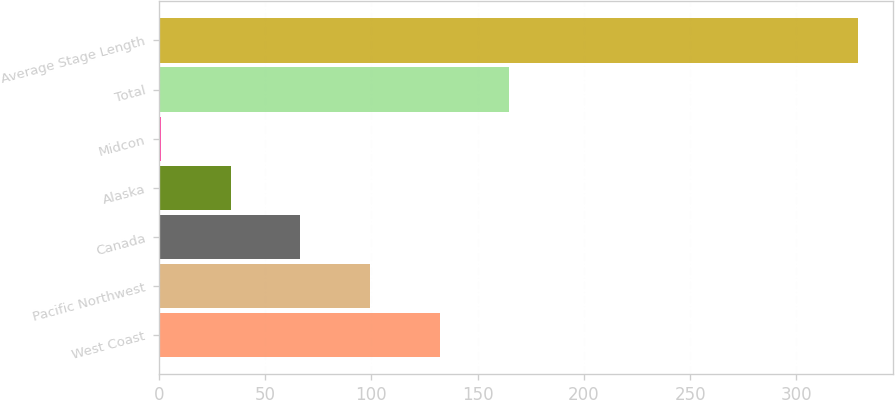Convert chart to OTSL. <chart><loc_0><loc_0><loc_500><loc_500><bar_chart><fcel>West Coast<fcel>Pacific Northwest<fcel>Canada<fcel>Alaska<fcel>Midcon<fcel>Total<fcel>Average Stage Length<nl><fcel>132.2<fcel>99.4<fcel>66.6<fcel>33.8<fcel>1<fcel>165<fcel>329<nl></chart> 